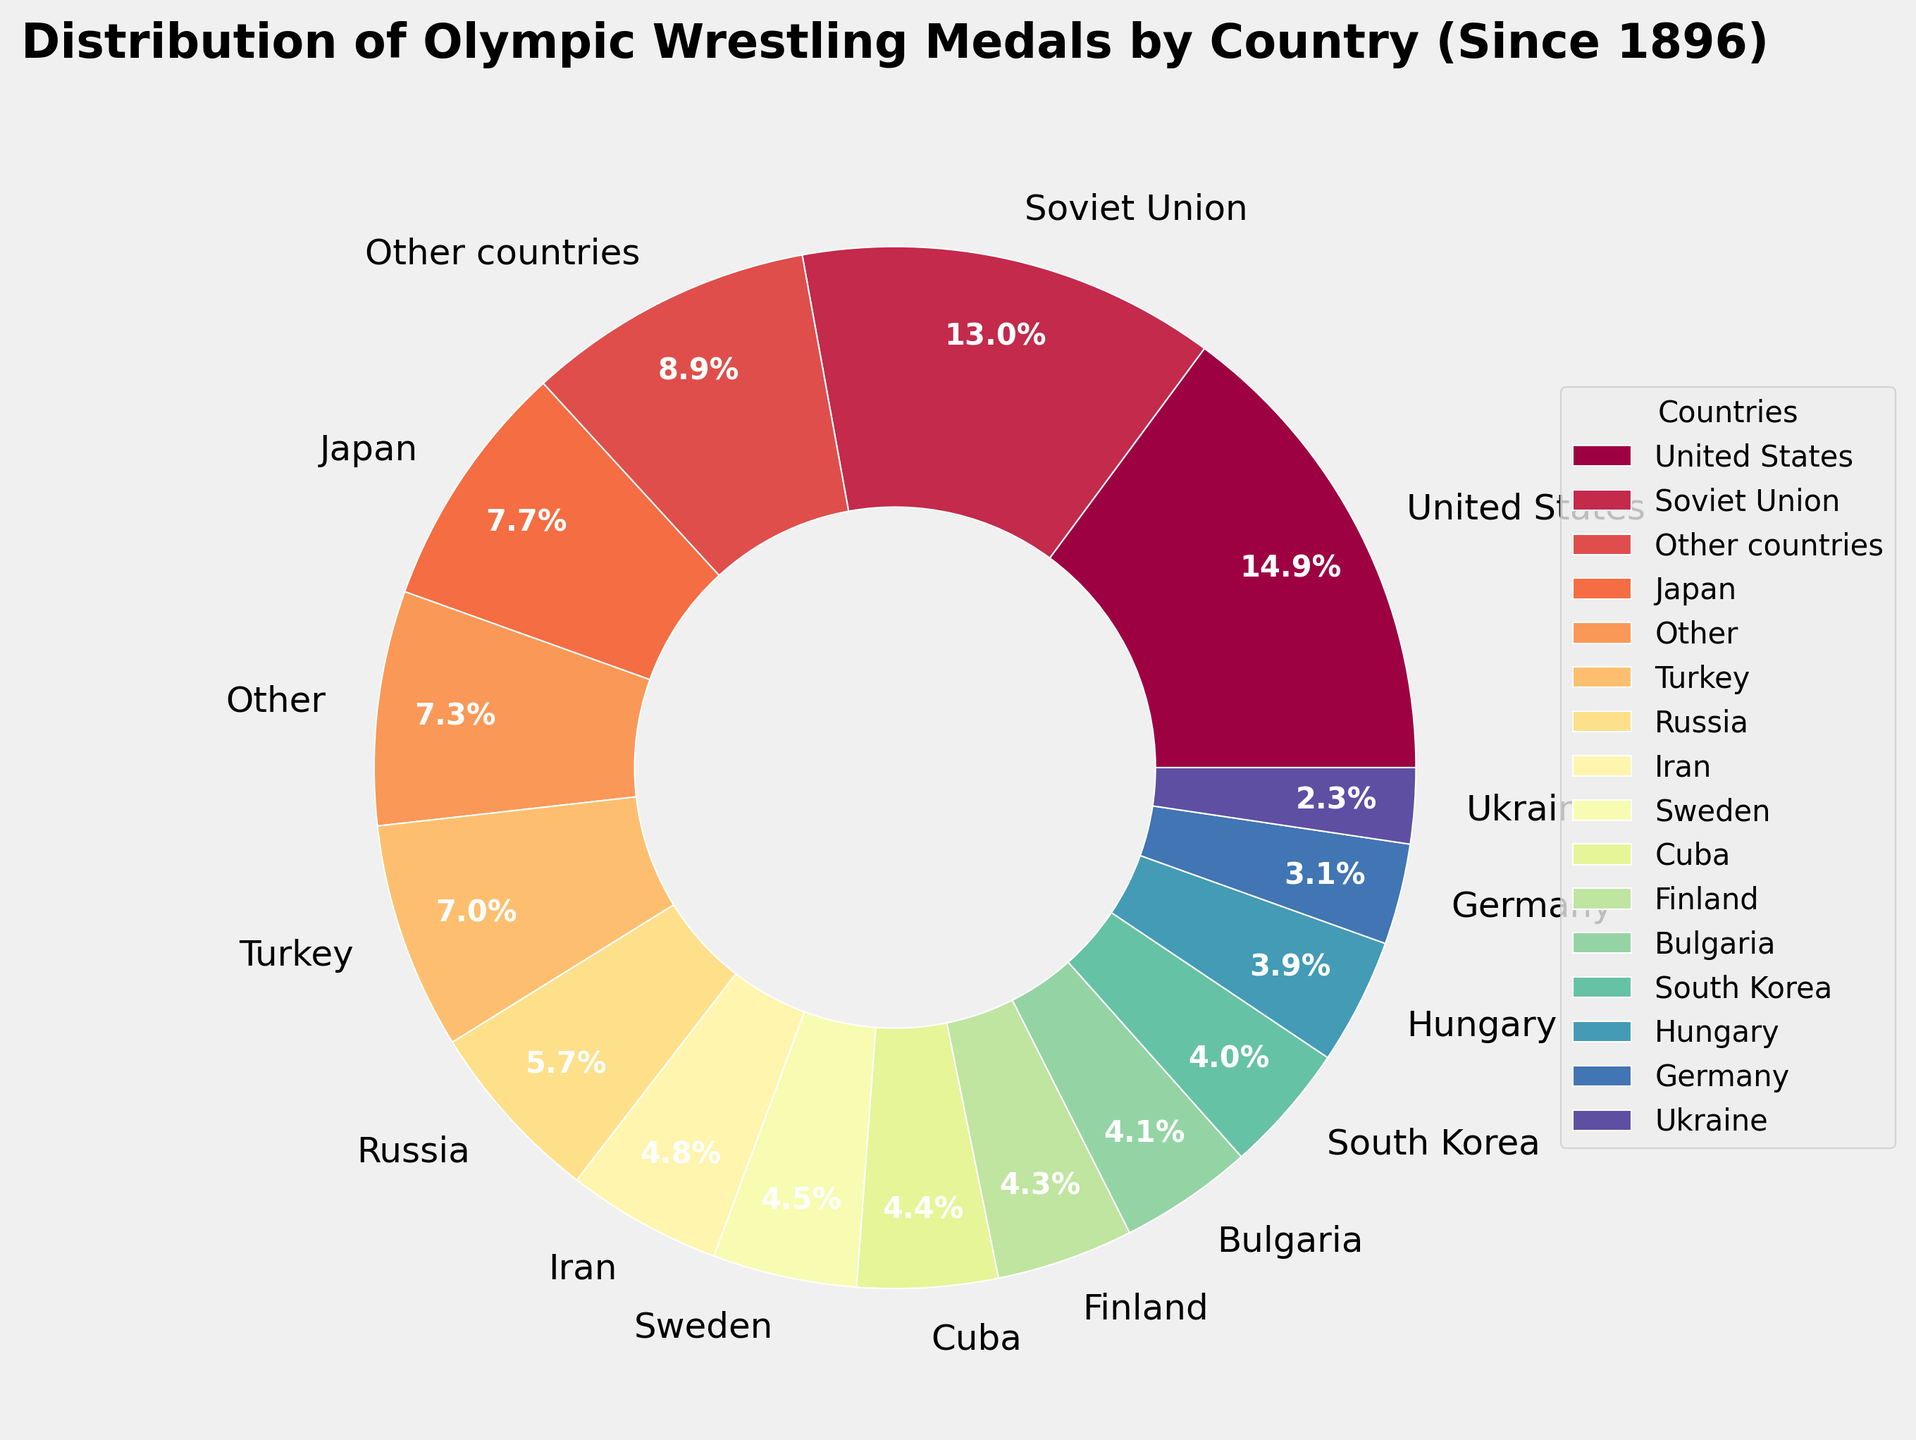Which country has won the most Olympic wrestling medals? The United States has the largest segment, visually distinguished near the top of the pie chart. The label indicates it has won 133 medals.
Answer: United States How many more medals has the United States won compared to Russia? The United States has won 133 medals and Russia has won 51 medals. The difference is calculated as 133 - 51.
Answer: 82 Among the countries with over 20 medals, which has won the fewest medals? Sorting through the segments representing countries with over 20 medals, Germany has the smallest slice with 28 medals.
Answer: Germany Which country has won more medals, Cuba or Bulgaria? By comparing their slices, Cuba has 39 medals while Bulgaria has 37 medals. Therefore, Cuba has won more.
Answer: Cuba If we combine the medals of South Korea and Hungary, how many total medals do they have together? Adding the medals of South Korea (36 medals) and Hungary (35 medals) gives a total of 36 + 35.
Answer: 71 How does the number of medals won by Japan compare to that of Turkey? The pie chart shows that Japan has 69 medals, and Turkey has 63 medals. The label shows Japan has won more.
Answer: Japan Which countries have won more medals than the combined total of Georgia and Azerbaijan? Georgia has 11 medals and Azerbaijan has 10, making their combined total 11 + 10 = 21. The countries with medals more than 21 are United States, Soviet Union, Russia, Japan, Turkey, Sweden, Finland, Iran, Bulgaria, Hungary, Cuba, South Korea, and Germany.
Answer: United States, Soviet Union, Russia, Japan, Turkey, Sweden, Finland, Iran, Bulgaria, Hungary, Cuba, South Korea, Germany How many countries have won at least 20 medals? From the pie chart, we count the segments with at least 20 medals: United States, Soviet Union, Russia, Japan, Turkey, Sweden, Finland, Iran, Bulgaria, Hungary, Cuba, South Korea, Germany, and Ukraine.
Answer: 14 What percentage of medals has the Soviet Union won? The Soviet Union has 116 medals. The total number of medals for countries meeting the threshold is the sum of all segments including "Other". Calculating the percentage: (116 / (sum(medals)) * 100). The total is the sum of [133, 116, 51, 69, 63, 40, 38, 43, 37, 35, 39, 36, 28, 21, 19, 80], equating to 1,168. Percent is (116/1,168) * 100.
Answer: 9.9% Which country has won more medals, Finland or Iran? Comparing their slices, Iran has 43 medals while Finland has 38 medals. Therefore, Iran has won more.
Answer: Iran 